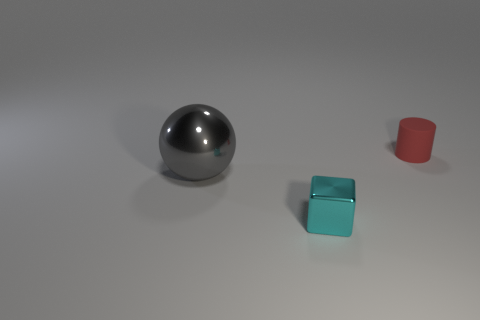What is the shape of the other tiny thing that is made of the same material as the gray thing?
Make the answer very short. Cube. Is the number of shiny spheres that are behind the large gray object greater than the number of small red cylinders that are behind the red cylinder?
Provide a succinct answer. No. What number of things are metallic cylinders or big balls?
Offer a terse response. 1. How many other objects are there of the same color as the rubber cylinder?
Offer a very short reply. 0. There is a thing that is the same size as the matte cylinder; what is its shape?
Make the answer very short. Cube. The tiny thing that is in front of the tiny red matte cylinder is what color?
Ensure brevity in your answer.  Cyan. How many things are either objects in front of the tiny red matte thing or things behind the cyan shiny thing?
Give a very brief answer. 3. Is the cylinder the same size as the shiny cube?
Offer a very short reply. Yes. What number of spheres are either small cyan things or tiny red objects?
Offer a terse response. 0. How many things are both in front of the matte object and on the right side of the gray metallic thing?
Provide a succinct answer. 1. 